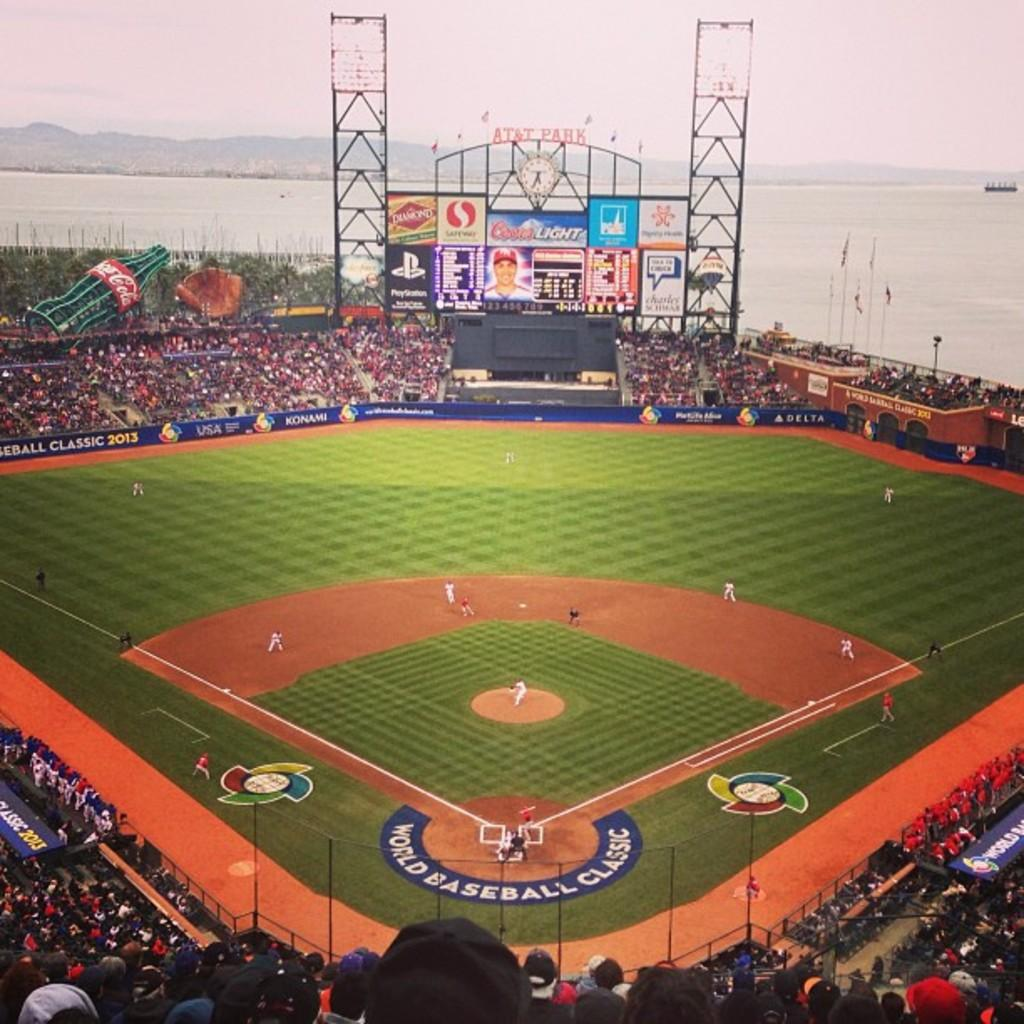<image>
Provide a brief description of the given image. A packed baseball field with an ongoing World Baseball Classic game. 